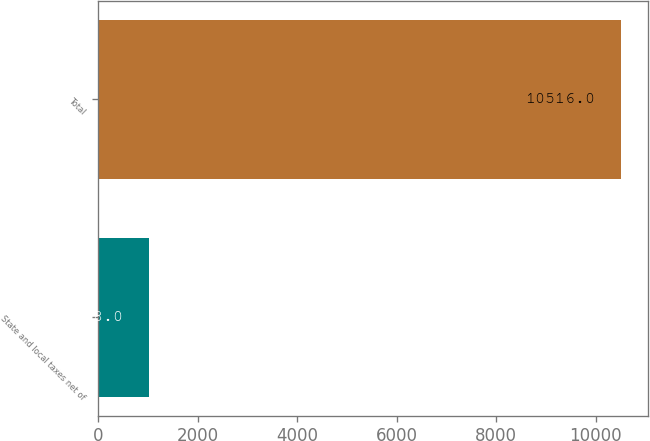<chart> <loc_0><loc_0><loc_500><loc_500><bar_chart><fcel>State and local taxes net of<fcel>Total<nl><fcel>1018<fcel>10516<nl></chart> 